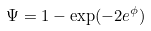<formula> <loc_0><loc_0><loc_500><loc_500>\Psi = 1 - \exp ( - 2 e ^ { \phi } )</formula> 